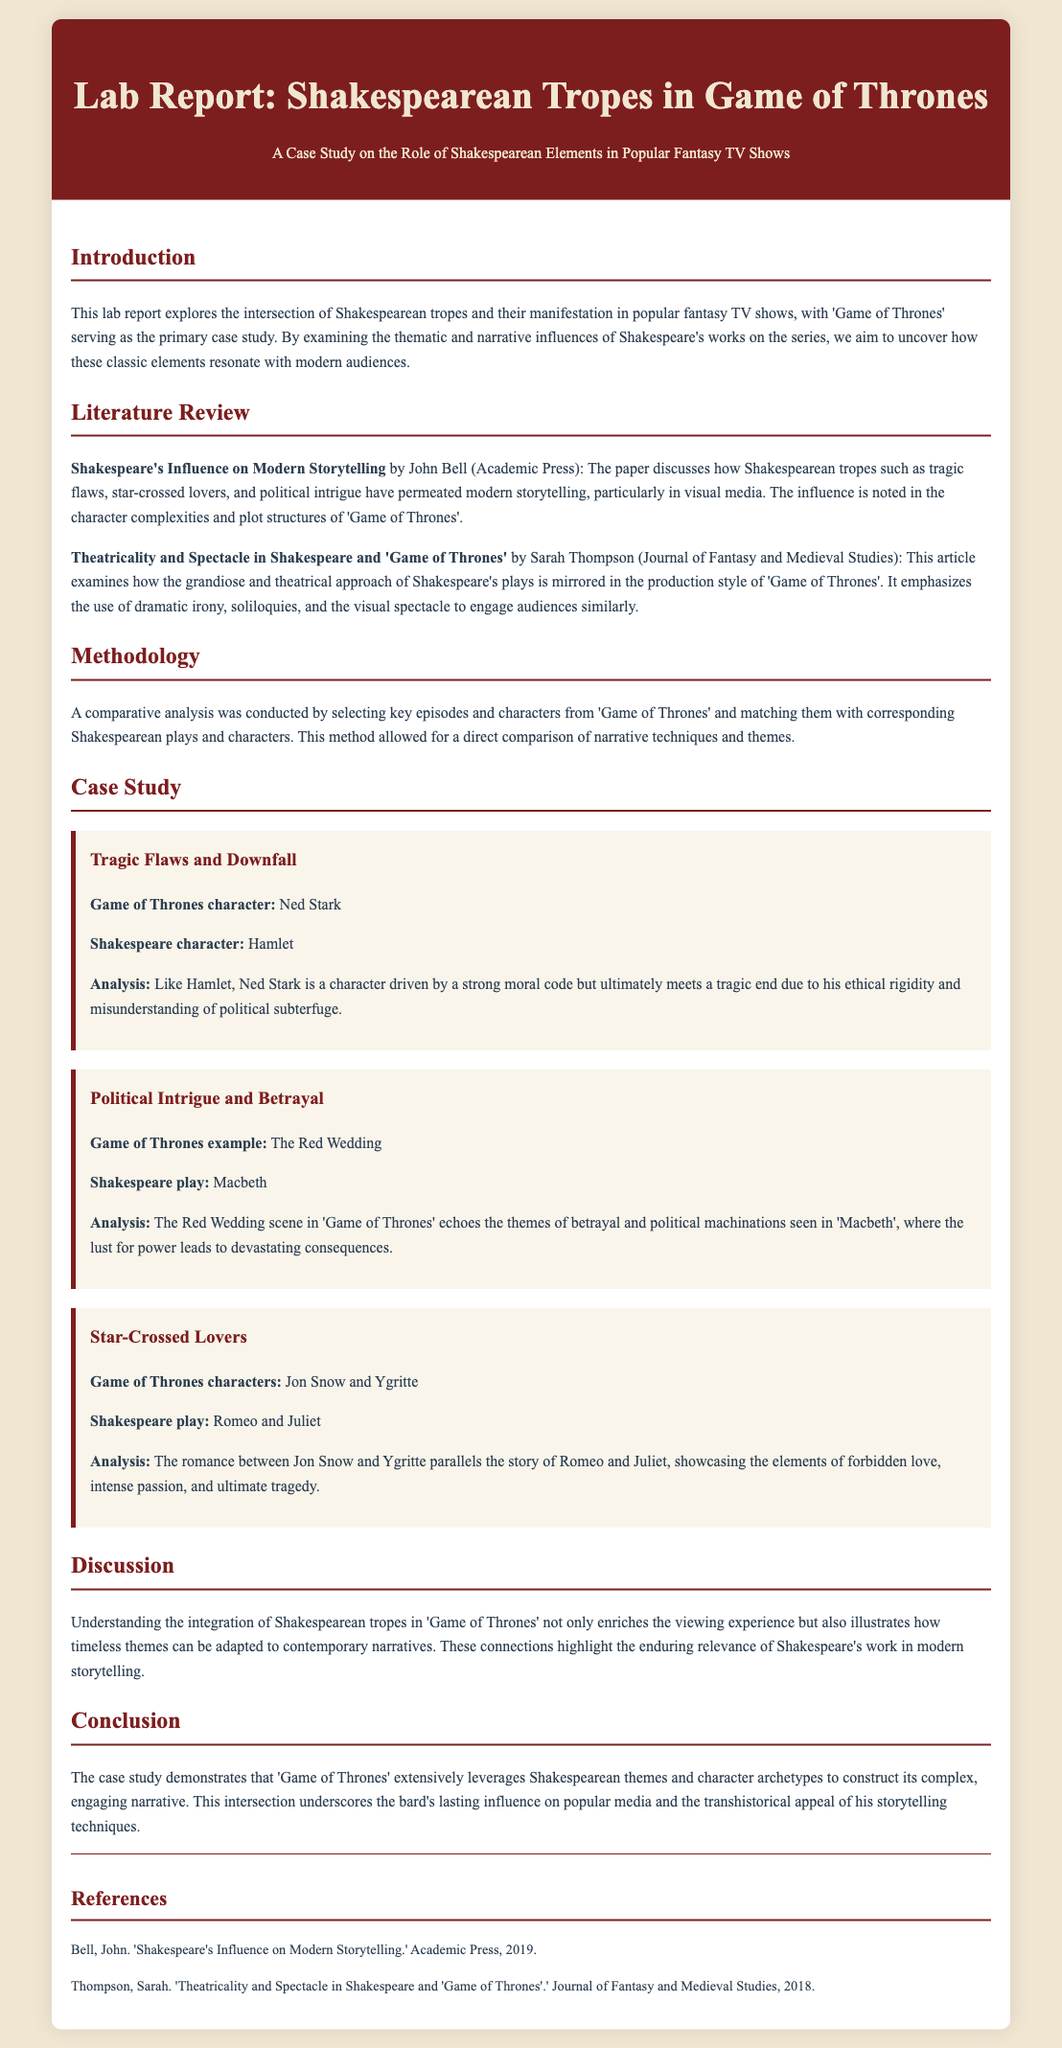What is the primary focus of the lab report? The lab report primarily focuses on the intersection of Shakespearean tropes and their manifestation in popular fantasy TV shows, with 'Game of Thrones' as the case study.
Answer: Intersection of Shakespearean tropes Who authored the paper on Shakespeare's influence on modern storytelling? The paper discussing Shakespeare's influence is authored by John Bell.
Answer: John Bell What is the name of the Game of Thrones character compared to Hamlet? The Game of Thrones character compared to Hamlet is Ned Stark.
Answer: Ned Stark What significant event in Game of Thrones is associated with the themes of betrayal and political machinations from Macbeth? The significant event in Game of Thrones associated with these themes is the Red Wedding.
Answer: The Red Wedding Which two characters from Game of Thrones are referenced as star-crossed lovers? The star-crossed lovers referenced from Game of Thrones are Jon Snow and Ygritte.
Answer: Jon Snow and Ygritte What year was John Bell's paper published? John Bell's paper was published in 2019.
Answer: 2019 What aspect of production style is examined in relation to both Shakespeare and Game of Thrones? The aspect examined is grandiose and theatrical approach.
Answer: Grandiose and theatrical approach What narrative technique is highlighted as a similarity between Shakespeare's plays and Game of Thrones? The use of dramatic irony is highlighted as a similarity.
Answer: Dramatic irony 